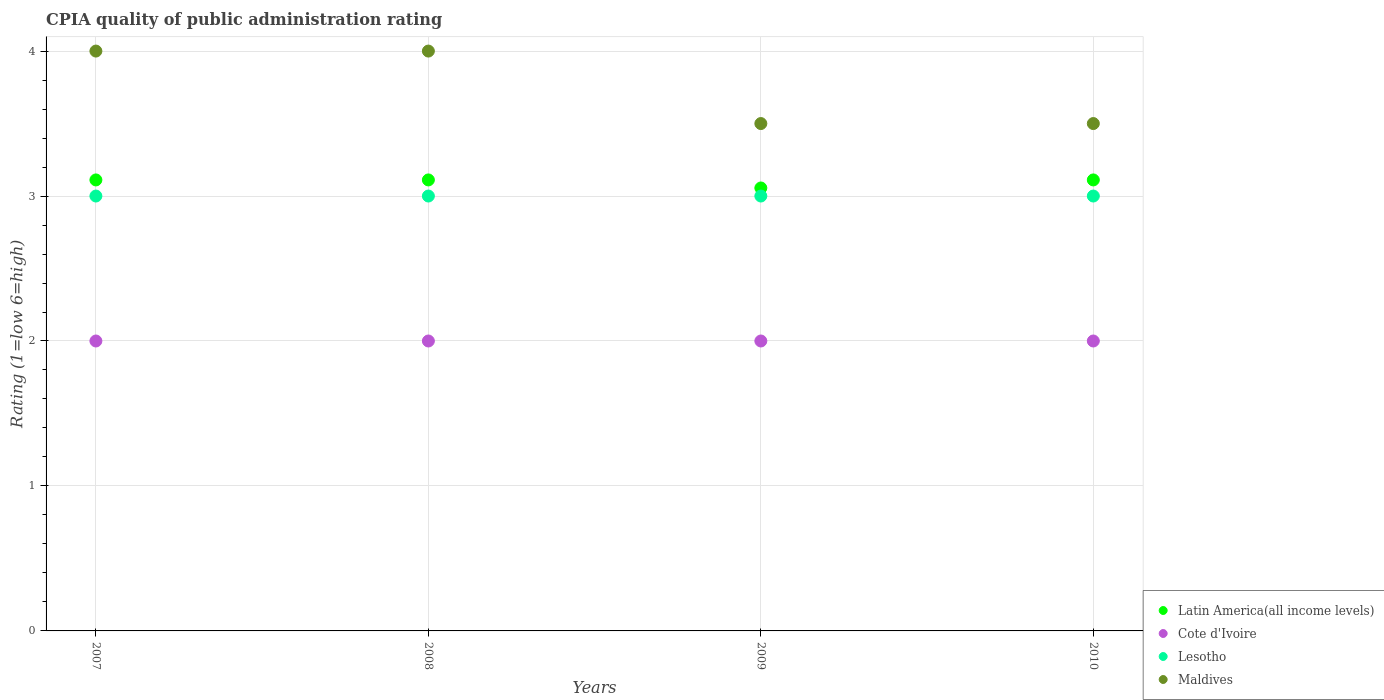Is the number of dotlines equal to the number of legend labels?
Provide a succinct answer. Yes. What is the CPIA rating in Latin America(all income levels) in 2010?
Offer a terse response. 3.11. Across all years, what is the minimum CPIA rating in Latin America(all income levels)?
Make the answer very short. 3.06. In which year was the CPIA rating in Latin America(all income levels) maximum?
Offer a terse response. 2007. In which year was the CPIA rating in Cote d'Ivoire minimum?
Offer a very short reply. 2007. What is the total CPIA rating in Latin America(all income levels) in the graph?
Your answer should be compact. 12.39. What is the difference between the CPIA rating in Cote d'Ivoire in 2008 and that in 2010?
Keep it short and to the point. 0. What is the average CPIA rating in Cote d'Ivoire per year?
Your response must be concise. 2. In the year 2008, what is the difference between the CPIA rating in Latin America(all income levels) and CPIA rating in Cote d'Ivoire?
Provide a succinct answer. 1.11. What is the ratio of the CPIA rating in Maldives in 2009 to that in 2010?
Offer a terse response. 1. Is it the case that in every year, the sum of the CPIA rating in Maldives and CPIA rating in Cote d'Ivoire  is greater than the CPIA rating in Latin America(all income levels)?
Your answer should be compact. Yes. Does the CPIA rating in Maldives monotonically increase over the years?
Offer a terse response. No. Is the CPIA rating in Maldives strictly less than the CPIA rating in Latin America(all income levels) over the years?
Give a very brief answer. No. What is the difference between two consecutive major ticks on the Y-axis?
Your response must be concise. 1. Are the values on the major ticks of Y-axis written in scientific E-notation?
Provide a succinct answer. No. Does the graph contain any zero values?
Provide a succinct answer. No. Where does the legend appear in the graph?
Ensure brevity in your answer.  Bottom right. How are the legend labels stacked?
Provide a short and direct response. Vertical. What is the title of the graph?
Offer a very short reply. CPIA quality of public administration rating. What is the label or title of the X-axis?
Provide a succinct answer. Years. What is the label or title of the Y-axis?
Ensure brevity in your answer.  Rating (1=low 6=high). What is the Rating (1=low 6=high) of Latin America(all income levels) in 2007?
Offer a terse response. 3.11. What is the Rating (1=low 6=high) of Lesotho in 2007?
Ensure brevity in your answer.  3. What is the Rating (1=low 6=high) of Maldives in 2007?
Your answer should be compact. 4. What is the Rating (1=low 6=high) of Latin America(all income levels) in 2008?
Ensure brevity in your answer.  3.11. What is the Rating (1=low 6=high) of Maldives in 2008?
Give a very brief answer. 4. What is the Rating (1=low 6=high) of Latin America(all income levels) in 2009?
Ensure brevity in your answer.  3.06. What is the Rating (1=low 6=high) of Cote d'Ivoire in 2009?
Ensure brevity in your answer.  2. What is the Rating (1=low 6=high) of Maldives in 2009?
Provide a short and direct response. 3.5. What is the Rating (1=low 6=high) in Latin America(all income levels) in 2010?
Provide a succinct answer. 3.11. What is the Rating (1=low 6=high) in Cote d'Ivoire in 2010?
Your answer should be very brief. 2. What is the Rating (1=low 6=high) in Lesotho in 2010?
Your response must be concise. 3. What is the Rating (1=low 6=high) of Maldives in 2010?
Provide a short and direct response. 3.5. Across all years, what is the maximum Rating (1=low 6=high) of Latin America(all income levels)?
Provide a succinct answer. 3.11. Across all years, what is the maximum Rating (1=low 6=high) in Cote d'Ivoire?
Your answer should be compact. 2. Across all years, what is the maximum Rating (1=low 6=high) in Lesotho?
Provide a succinct answer. 3. Across all years, what is the minimum Rating (1=low 6=high) in Latin America(all income levels)?
Your answer should be compact. 3.06. Across all years, what is the minimum Rating (1=low 6=high) in Cote d'Ivoire?
Give a very brief answer. 2. Across all years, what is the minimum Rating (1=low 6=high) of Maldives?
Your answer should be very brief. 3.5. What is the total Rating (1=low 6=high) in Latin America(all income levels) in the graph?
Your answer should be compact. 12.39. What is the total Rating (1=low 6=high) in Cote d'Ivoire in the graph?
Your answer should be compact. 8. What is the total Rating (1=low 6=high) of Lesotho in the graph?
Provide a succinct answer. 12. What is the total Rating (1=low 6=high) of Maldives in the graph?
Your answer should be compact. 15. What is the difference between the Rating (1=low 6=high) of Latin America(all income levels) in 2007 and that in 2008?
Ensure brevity in your answer.  0. What is the difference between the Rating (1=low 6=high) of Latin America(all income levels) in 2007 and that in 2009?
Your answer should be compact. 0.06. What is the difference between the Rating (1=low 6=high) of Cote d'Ivoire in 2007 and that in 2009?
Keep it short and to the point. 0. What is the difference between the Rating (1=low 6=high) of Maldives in 2007 and that in 2009?
Ensure brevity in your answer.  0.5. What is the difference between the Rating (1=low 6=high) in Latin America(all income levels) in 2007 and that in 2010?
Provide a short and direct response. 0. What is the difference between the Rating (1=low 6=high) of Cote d'Ivoire in 2007 and that in 2010?
Your answer should be compact. 0. What is the difference between the Rating (1=low 6=high) in Lesotho in 2007 and that in 2010?
Provide a succinct answer. 0. What is the difference between the Rating (1=low 6=high) of Latin America(all income levels) in 2008 and that in 2009?
Offer a terse response. 0.06. What is the difference between the Rating (1=low 6=high) in Cote d'Ivoire in 2008 and that in 2009?
Your answer should be very brief. 0. What is the difference between the Rating (1=low 6=high) of Lesotho in 2008 and that in 2009?
Make the answer very short. 0. What is the difference between the Rating (1=low 6=high) of Latin America(all income levels) in 2008 and that in 2010?
Your answer should be compact. 0. What is the difference between the Rating (1=low 6=high) in Latin America(all income levels) in 2009 and that in 2010?
Your answer should be compact. -0.06. What is the difference between the Rating (1=low 6=high) in Cote d'Ivoire in 2009 and that in 2010?
Offer a terse response. 0. What is the difference between the Rating (1=low 6=high) in Latin America(all income levels) in 2007 and the Rating (1=low 6=high) in Cote d'Ivoire in 2008?
Ensure brevity in your answer.  1.11. What is the difference between the Rating (1=low 6=high) in Latin America(all income levels) in 2007 and the Rating (1=low 6=high) in Lesotho in 2008?
Provide a succinct answer. 0.11. What is the difference between the Rating (1=low 6=high) of Latin America(all income levels) in 2007 and the Rating (1=low 6=high) of Maldives in 2008?
Your answer should be compact. -0.89. What is the difference between the Rating (1=low 6=high) of Cote d'Ivoire in 2007 and the Rating (1=low 6=high) of Lesotho in 2008?
Offer a terse response. -1. What is the difference between the Rating (1=low 6=high) in Cote d'Ivoire in 2007 and the Rating (1=low 6=high) in Maldives in 2008?
Offer a very short reply. -2. What is the difference between the Rating (1=low 6=high) in Lesotho in 2007 and the Rating (1=low 6=high) in Maldives in 2008?
Offer a very short reply. -1. What is the difference between the Rating (1=low 6=high) in Latin America(all income levels) in 2007 and the Rating (1=low 6=high) in Maldives in 2009?
Your answer should be very brief. -0.39. What is the difference between the Rating (1=low 6=high) of Cote d'Ivoire in 2007 and the Rating (1=low 6=high) of Lesotho in 2009?
Keep it short and to the point. -1. What is the difference between the Rating (1=low 6=high) in Lesotho in 2007 and the Rating (1=low 6=high) in Maldives in 2009?
Ensure brevity in your answer.  -0.5. What is the difference between the Rating (1=low 6=high) of Latin America(all income levels) in 2007 and the Rating (1=low 6=high) of Cote d'Ivoire in 2010?
Give a very brief answer. 1.11. What is the difference between the Rating (1=low 6=high) of Latin America(all income levels) in 2007 and the Rating (1=low 6=high) of Maldives in 2010?
Provide a short and direct response. -0.39. What is the difference between the Rating (1=low 6=high) in Latin America(all income levels) in 2008 and the Rating (1=low 6=high) in Cote d'Ivoire in 2009?
Provide a succinct answer. 1.11. What is the difference between the Rating (1=low 6=high) in Latin America(all income levels) in 2008 and the Rating (1=low 6=high) in Lesotho in 2009?
Make the answer very short. 0.11. What is the difference between the Rating (1=low 6=high) in Latin America(all income levels) in 2008 and the Rating (1=low 6=high) in Maldives in 2009?
Your answer should be compact. -0.39. What is the difference between the Rating (1=low 6=high) of Cote d'Ivoire in 2008 and the Rating (1=low 6=high) of Lesotho in 2009?
Offer a terse response. -1. What is the difference between the Rating (1=low 6=high) in Latin America(all income levels) in 2008 and the Rating (1=low 6=high) in Cote d'Ivoire in 2010?
Provide a short and direct response. 1.11. What is the difference between the Rating (1=low 6=high) in Latin America(all income levels) in 2008 and the Rating (1=low 6=high) in Maldives in 2010?
Make the answer very short. -0.39. What is the difference between the Rating (1=low 6=high) in Cote d'Ivoire in 2008 and the Rating (1=low 6=high) in Lesotho in 2010?
Keep it short and to the point. -1. What is the difference between the Rating (1=low 6=high) in Cote d'Ivoire in 2008 and the Rating (1=low 6=high) in Maldives in 2010?
Offer a very short reply. -1.5. What is the difference between the Rating (1=low 6=high) of Lesotho in 2008 and the Rating (1=low 6=high) of Maldives in 2010?
Your answer should be compact. -0.5. What is the difference between the Rating (1=low 6=high) of Latin America(all income levels) in 2009 and the Rating (1=low 6=high) of Cote d'Ivoire in 2010?
Give a very brief answer. 1.06. What is the difference between the Rating (1=low 6=high) in Latin America(all income levels) in 2009 and the Rating (1=low 6=high) in Lesotho in 2010?
Your answer should be compact. 0.06. What is the difference between the Rating (1=low 6=high) in Latin America(all income levels) in 2009 and the Rating (1=low 6=high) in Maldives in 2010?
Make the answer very short. -0.44. What is the difference between the Rating (1=low 6=high) in Lesotho in 2009 and the Rating (1=low 6=high) in Maldives in 2010?
Provide a short and direct response. -0.5. What is the average Rating (1=low 6=high) of Latin America(all income levels) per year?
Provide a short and direct response. 3.1. What is the average Rating (1=low 6=high) of Cote d'Ivoire per year?
Your response must be concise. 2. What is the average Rating (1=low 6=high) in Maldives per year?
Your response must be concise. 3.75. In the year 2007, what is the difference between the Rating (1=low 6=high) in Latin America(all income levels) and Rating (1=low 6=high) in Lesotho?
Provide a succinct answer. 0.11. In the year 2007, what is the difference between the Rating (1=low 6=high) in Latin America(all income levels) and Rating (1=low 6=high) in Maldives?
Offer a very short reply. -0.89. In the year 2007, what is the difference between the Rating (1=low 6=high) of Cote d'Ivoire and Rating (1=low 6=high) of Lesotho?
Provide a short and direct response. -1. In the year 2007, what is the difference between the Rating (1=low 6=high) of Cote d'Ivoire and Rating (1=low 6=high) of Maldives?
Provide a succinct answer. -2. In the year 2008, what is the difference between the Rating (1=low 6=high) of Latin America(all income levels) and Rating (1=low 6=high) of Lesotho?
Your response must be concise. 0.11. In the year 2008, what is the difference between the Rating (1=low 6=high) in Latin America(all income levels) and Rating (1=low 6=high) in Maldives?
Your answer should be very brief. -0.89. In the year 2009, what is the difference between the Rating (1=low 6=high) in Latin America(all income levels) and Rating (1=low 6=high) in Cote d'Ivoire?
Your answer should be compact. 1.06. In the year 2009, what is the difference between the Rating (1=low 6=high) in Latin America(all income levels) and Rating (1=low 6=high) in Lesotho?
Provide a short and direct response. 0.06. In the year 2009, what is the difference between the Rating (1=low 6=high) in Latin America(all income levels) and Rating (1=low 6=high) in Maldives?
Provide a succinct answer. -0.44. In the year 2009, what is the difference between the Rating (1=low 6=high) in Cote d'Ivoire and Rating (1=low 6=high) in Lesotho?
Make the answer very short. -1. In the year 2009, what is the difference between the Rating (1=low 6=high) in Lesotho and Rating (1=low 6=high) in Maldives?
Offer a very short reply. -0.5. In the year 2010, what is the difference between the Rating (1=low 6=high) in Latin America(all income levels) and Rating (1=low 6=high) in Cote d'Ivoire?
Offer a very short reply. 1.11. In the year 2010, what is the difference between the Rating (1=low 6=high) in Latin America(all income levels) and Rating (1=low 6=high) in Maldives?
Provide a short and direct response. -0.39. In the year 2010, what is the difference between the Rating (1=low 6=high) in Cote d'Ivoire and Rating (1=low 6=high) in Maldives?
Provide a succinct answer. -1.5. In the year 2010, what is the difference between the Rating (1=low 6=high) of Lesotho and Rating (1=low 6=high) of Maldives?
Your answer should be compact. -0.5. What is the ratio of the Rating (1=low 6=high) of Cote d'Ivoire in 2007 to that in 2008?
Make the answer very short. 1. What is the ratio of the Rating (1=low 6=high) in Latin America(all income levels) in 2007 to that in 2009?
Make the answer very short. 1.02. What is the ratio of the Rating (1=low 6=high) in Cote d'Ivoire in 2007 to that in 2009?
Give a very brief answer. 1. What is the ratio of the Rating (1=low 6=high) in Latin America(all income levels) in 2007 to that in 2010?
Give a very brief answer. 1. What is the ratio of the Rating (1=low 6=high) in Cote d'Ivoire in 2007 to that in 2010?
Provide a short and direct response. 1. What is the ratio of the Rating (1=low 6=high) of Lesotho in 2007 to that in 2010?
Make the answer very short. 1. What is the ratio of the Rating (1=low 6=high) of Maldives in 2007 to that in 2010?
Provide a succinct answer. 1.14. What is the ratio of the Rating (1=low 6=high) of Latin America(all income levels) in 2008 to that in 2009?
Provide a short and direct response. 1.02. What is the ratio of the Rating (1=low 6=high) in Cote d'Ivoire in 2008 to that in 2009?
Give a very brief answer. 1. What is the ratio of the Rating (1=low 6=high) of Lesotho in 2008 to that in 2009?
Your answer should be compact. 1. What is the ratio of the Rating (1=low 6=high) in Cote d'Ivoire in 2008 to that in 2010?
Offer a very short reply. 1. What is the ratio of the Rating (1=low 6=high) of Lesotho in 2008 to that in 2010?
Offer a terse response. 1. What is the ratio of the Rating (1=low 6=high) in Latin America(all income levels) in 2009 to that in 2010?
Your answer should be compact. 0.98. What is the ratio of the Rating (1=low 6=high) in Maldives in 2009 to that in 2010?
Your response must be concise. 1. What is the difference between the highest and the second highest Rating (1=low 6=high) of Lesotho?
Ensure brevity in your answer.  0. What is the difference between the highest and the lowest Rating (1=low 6=high) of Latin America(all income levels)?
Your response must be concise. 0.06. What is the difference between the highest and the lowest Rating (1=low 6=high) of Maldives?
Your answer should be compact. 0.5. 